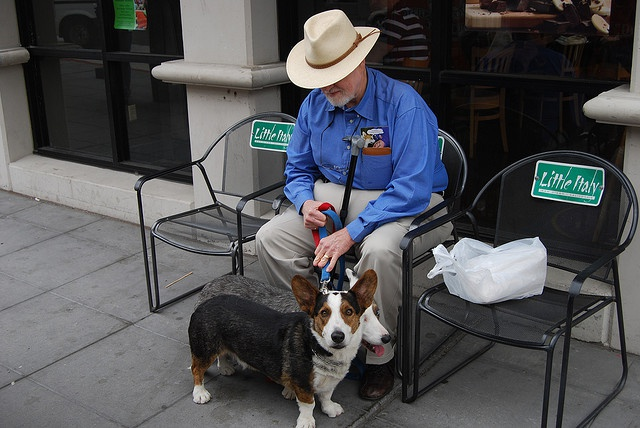Describe the objects in this image and their specific colors. I can see chair in black, gray, teal, and darkgray tones, people in black, blue, darkgray, and gray tones, chair in black, gray, darkgray, and teal tones, dog in black, darkgray, gray, and maroon tones, and people in black tones in this image. 